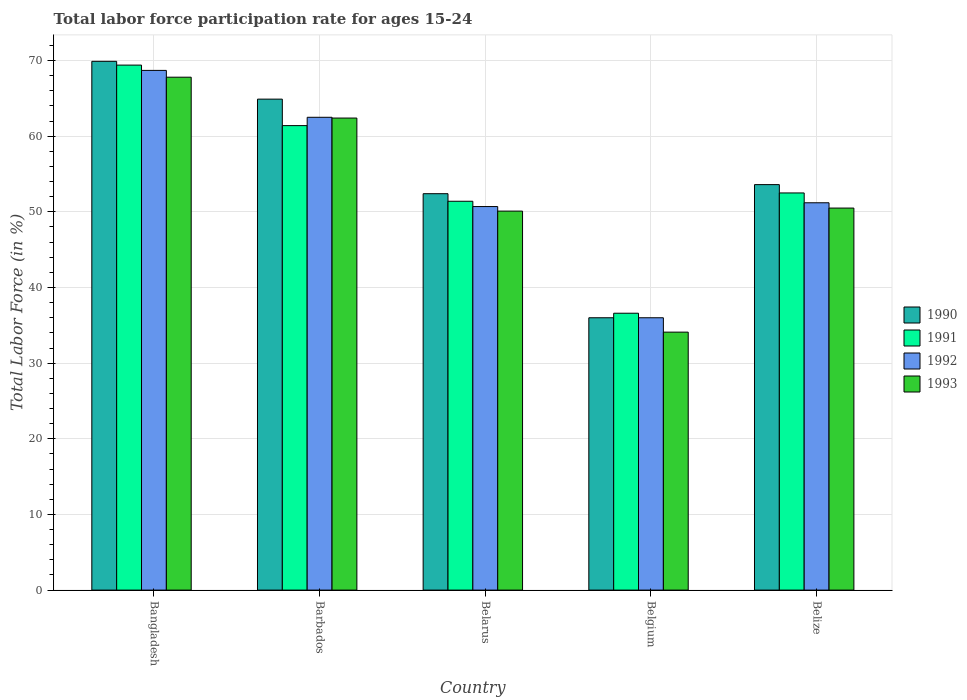Are the number of bars per tick equal to the number of legend labels?
Give a very brief answer. Yes. Are the number of bars on each tick of the X-axis equal?
Make the answer very short. Yes. How many bars are there on the 2nd tick from the left?
Offer a terse response. 4. How many bars are there on the 5th tick from the right?
Provide a succinct answer. 4. What is the label of the 3rd group of bars from the left?
Ensure brevity in your answer.  Belarus. What is the labor force participation rate in 1990 in Belize?
Offer a very short reply. 53.6. Across all countries, what is the maximum labor force participation rate in 1992?
Offer a very short reply. 68.7. Across all countries, what is the minimum labor force participation rate in 1993?
Offer a very short reply. 34.1. In which country was the labor force participation rate in 1991 maximum?
Give a very brief answer. Bangladesh. In which country was the labor force participation rate in 1992 minimum?
Ensure brevity in your answer.  Belgium. What is the total labor force participation rate in 1992 in the graph?
Ensure brevity in your answer.  269.1. What is the difference between the labor force participation rate in 1992 in Bangladesh and that in Barbados?
Provide a succinct answer. 6.2. What is the difference between the labor force participation rate in 1991 in Belarus and the labor force participation rate in 1992 in Barbados?
Make the answer very short. -11.1. What is the average labor force participation rate in 1992 per country?
Your response must be concise. 53.82. What is the difference between the labor force participation rate of/in 1990 and labor force participation rate of/in 1992 in Barbados?
Keep it short and to the point. 2.4. In how many countries, is the labor force participation rate in 1990 greater than 56 %?
Make the answer very short. 2. What is the ratio of the labor force participation rate in 1993 in Barbados to that in Belarus?
Provide a succinct answer. 1.25. What is the difference between the highest and the second highest labor force participation rate in 1990?
Your response must be concise. 11.3. What is the difference between the highest and the lowest labor force participation rate in 1993?
Provide a succinct answer. 33.7. In how many countries, is the labor force participation rate in 1993 greater than the average labor force participation rate in 1993 taken over all countries?
Make the answer very short. 2. Is it the case that in every country, the sum of the labor force participation rate in 1991 and labor force participation rate in 1990 is greater than the sum of labor force participation rate in 1993 and labor force participation rate in 1992?
Provide a short and direct response. No. What does the 4th bar from the left in Belarus represents?
Ensure brevity in your answer.  1993. Is it the case that in every country, the sum of the labor force participation rate in 1990 and labor force participation rate in 1992 is greater than the labor force participation rate in 1991?
Provide a short and direct response. Yes. Are the values on the major ticks of Y-axis written in scientific E-notation?
Make the answer very short. No. Does the graph contain any zero values?
Make the answer very short. No. Where does the legend appear in the graph?
Keep it short and to the point. Center right. How are the legend labels stacked?
Your answer should be compact. Vertical. What is the title of the graph?
Give a very brief answer. Total labor force participation rate for ages 15-24. What is the label or title of the X-axis?
Provide a succinct answer. Country. What is the label or title of the Y-axis?
Your answer should be very brief. Total Labor Force (in %). What is the Total Labor Force (in %) in 1990 in Bangladesh?
Keep it short and to the point. 69.9. What is the Total Labor Force (in %) in 1991 in Bangladesh?
Provide a short and direct response. 69.4. What is the Total Labor Force (in %) of 1992 in Bangladesh?
Make the answer very short. 68.7. What is the Total Labor Force (in %) in 1993 in Bangladesh?
Offer a very short reply. 67.8. What is the Total Labor Force (in %) in 1990 in Barbados?
Provide a succinct answer. 64.9. What is the Total Labor Force (in %) in 1991 in Barbados?
Keep it short and to the point. 61.4. What is the Total Labor Force (in %) in 1992 in Barbados?
Offer a very short reply. 62.5. What is the Total Labor Force (in %) of 1993 in Barbados?
Make the answer very short. 62.4. What is the Total Labor Force (in %) of 1990 in Belarus?
Provide a short and direct response. 52.4. What is the Total Labor Force (in %) of 1991 in Belarus?
Provide a short and direct response. 51.4. What is the Total Labor Force (in %) in 1992 in Belarus?
Provide a short and direct response. 50.7. What is the Total Labor Force (in %) of 1993 in Belarus?
Keep it short and to the point. 50.1. What is the Total Labor Force (in %) in 1991 in Belgium?
Your answer should be compact. 36.6. What is the Total Labor Force (in %) in 1992 in Belgium?
Your answer should be compact. 36. What is the Total Labor Force (in %) of 1993 in Belgium?
Make the answer very short. 34.1. What is the Total Labor Force (in %) of 1990 in Belize?
Make the answer very short. 53.6. What is the Total Labor Force (in %) in 1991 in Belize?
Provide a short and direct response. 52.5. What is the Total Labor Force (in %) of 1992 in Belize?
Your response must be concise. 51.2. What is the Total Labor Force (in %) in 1993 in Belize?
Your response must be concise. 50.5. Across all countries, what is the maximum Total Labor Force (in %) in 1990?
Your response must be concise. 69.9. Across all countries, what is the maximum Total Labor Force (in %) of 1991?
Your answer should be compact. 69.4. Across all countries, what is the maximum Total Labor Force (in %) of 1992?
Provide a short and direct response. 68.7. Across all countries, what is the maximum Total Labor Force (in %) of 1993?
Keep it short and to the point. 67.8. Across all countries, what is the minimum Total Labor Force (in %) in 1991?
Provide a succinct answer. 36.6. Across all countries, what is the minimum Total Labor Force (in %) in 1992?
Keep it short and to the point. 36. Across all countries, what is the minimum Total Labor Force (in %) of 1993?
Provide a succinct answer. 34.1. What is the total Total Labor Force (in %) of 1990 in the graph?
Make the answer very short. 276.8. What is the total Total Labor Force (in %) in 1991 in the graph?
Your answer should be compact. 271.3. What is the total Total Labor Force (in %) in 1992 in the graph?
Offer a very short reply. 269.1. What is the total Total Labor Force (in %) of 1993 in the graph?
Make the answer very short. 264.9. What is the difference between the Total Labor Force (in %) in 1991 in Bangladesh and that in Belarus?
Your response must be concise. 18. What is the difference between the Total Labor Force (in %) in 1993 in Bangladesh and that in Belarus?
Offer a terse response. 17.7. What is the difference between the Total Labor Force (in %) of 1990 in Bangladesh and that in Belgium?
Provide a short and direct response. 33.9. What is the difference between the Total Labor Force (in %) in 1991 in Bangladesh and that in Belgium?
Offer a very short reply. 32.8. What is the difference between the Total Labor Force (in %) of 1992 in Bangladesh and that in Belgium?
Your response must be concise. 32.7. What is the difference between the Total Labor Force (in %) in 1993 in Bangladesh and that in Belgium?
Your response must be concise. 33.7. What is the difference between the Total Labor Force (in %) in 1991 in Bangladesh and that in Belize?
Give a very brief answer. 16.9. What is the difference between the Total Labor Force (in %) of 1990 in Barbados and that in Belarus?
Provide a short and direct response. 12.5. What is the difference between the Total Labor Force (in %) in 1990 in Barbados and that in Belgium?
Offer a terse response. 28.9. What is the difference between the Total Labor Force (in %) in 1991 in Barbados and that in Belgium?
Keep it short and to the point. 24.8. What is the difference between the Total Labor Force (in %) of 1993 in Barbados and that in Belgium?
Provide a succinct answer. 28.3. What is the difference between the Total Labor Force (in %) in 1990 in Barbados and that in Belize?
Your answer should be compact. 11.3. What is the difference between the Total Labor Force (in %) of 1991 in Barbados and that in Belize?
Provide a short and direct response. 8.9. What is the difference between the Total Labor Force (in %) of 1991 in Belarus and that in Belgium?
Provide a succinct answer. 14.8. What is the difference between the Total Labor Force (in %) in 1992 in Belarus and that in Belgium?
Offer a terse response. 14.7. What is the difference between the Total Labor Force (in %) of 1991 in Belarus and that in Belize?
Provide a short and direct response. -1.1. What is the difference between the Total Labor Force (in %) in 1992 in Belarus and that in Belize?
Your answer should be very brief. -0.5. What is the difference between the Total Labor Force (in %) of 1990 in Belgium and that in Belize?
Your answer should be very brief. -17.6. What is the difference between the Total Labor Force (in %) in 1991 in Belgium and that in Belize?
Offer a very short reply. -15.9. What is the difference between the Total Labor Force (in %) in 1992 in Belgium and that in Belize?
Make the answer very short. -15.2. What is the difference between the Total Labor Force (in %) of 1993 in Belgium and that in Belize?
Ensure brevity in your answer.  -16.4. What is the difference between the Total Labor Force (in %) of 1990 in Bangladesh and the Total Labor Force (in %) of 1992 in Barbados?
Provide a short and direct response. 7.4. What is the difference between the Total Labor Force (in %) in 1991 in Bangladesh and the Total Labor Force (in %) in 1993 in Barbados?
Keep it short and to the point. 7. What is the difference between the Total Labor Force (in %) of 1992 in Bangladesh and the Total Labor Force (in %) of 1993 in Barbados?
Offer a terse response. 6.3. What is the difference between the Total Labor Force (in %) in 1990 in Bangladesh and the Total Labor Force (in %) in 1991 in Belarus?
Offer a terse response. 18.5. What is the difference between the Total Labor Force (in %) in 1990 in Bangladesh and the Total Labor Force (in %) in 1993 in Belarus?
Offer a terse response. 19.8. What is the difference between the Total Labor Force (in %) of 1991 in Bangladesh and the Total Labor Force (in %) of 1993 in Belarus?
Your response must be concise. 19.3. What is the difference between the Total Labor Force (in %) in 1992 in Bangladesh and the Total Labor Force (in %) in 1993 in Belarus?
Offer a terse response. 18.6. What is the difference between the Total Labor Force (in %) of 1990 in Bangladesh and the Total Labor Force (in %) of 1991 in Belgium?
Your response must be concise. 33.3. What is the difference between the Total Labor Force (in %) of 1990 in Bangladesh and the Total Labor Force (in %) of 1992 in Belgium?
Your response must be concise. 33.9. What is the difference between the Total Labor Force (in %) of 1990 in Bangladesh and the Total Labor Force (in %) of 1993 in Belgium?
Make the answer very short. 35.8. What is the difference between the Total Labor Force (in %) in 1991 in Bangladesh and the Total Labor Force (in %) in 1992 in Belgium?
Your answer should be compact. 33.4. What is the difference between the Total Labor Force (in %) of 1991 in Bangladesh and the Total Labor Force (in %) of 1993 in Belgium?
Your answer should be compact. 35.3. What is the difference between the Total Labor Force (in %) of 1992 in Bangladesh and the Total Labor Force (in %) of 1993 in Belgium?
Give a very brief answer. 34.6. What is the difference between the Total Labor Force (in %) of 1990 in Bangladesh and the Total Labor Force (in %) of 1991 in Belize?
Your response must be concise. 17.4. What is the difference between the Total Labor Force (in %) of 1990 in Bangladesh and the Total Labor Force (in %) of 1992 in Belize?
Your answer should be very brief. 18.7. What is the difference between the Total Labor Force (in %) of 1990 in Bangladesh and the Total Labor Force (in %) of 1993 in Belize?
Ensure brevity in your answer.  19.4. What is the difference between the Total Labor Force (in %) in 1991 in Bangladesh and the Total Labor Force (in %) in 1993 in Belize?
Ensure brevity in your answer.  18.9. What is the difference between the Total Labor Force (in %) in 1992 in Bangladesh and the Total Labor Force (in %) in 1993 in Belize?
Keep it short and to the point. 18.2. What is the difference between the Total Labor Force (in %) of 1990 in Barbados and the Total Labor Force (in %) of 1992 in Belarus?
Provide a succinct answer. 14.2. What is the difference between the Total Labor Force (in %) in 1990 in Barbados and the Total Labor Force (in %) in 1993 in Belarus?
Your response must be concise. 14.8. What is the difference between the Total Labor Force (in %) in 1991 in Barbados and the Total Labor Force (in %) in 1992 in Belarus?
Make the answer very short. 10.7. What is the difference between the Total Labor Force (in %) of 1992 in Barbados and the Total Labor Force (in %) of 1993 in Belarus?
Your answer should be compact. 12.4. What is the difference between the Total Labor Force (in %) of 1990 in Barbados and the Total Labor Force (in %) of 1991 in Belgium?
Your response must be concise. 28.3. What is the difference between the Total Labor Force (in %) in 1990 in Barbados and the Total Labor Force (in %) in 1992 in Belgium?
Your answer should be very brief. 28.9. What is the difference between the Total Labor Force (in %) of 1990 in Barbados and the Total Labor Force (in %) of 1993 in Belgium?
Your answer should be very brief. 30.8. What is the difference between the Total Labor Force (in %) of 1991 in Barbados and the Total Labor Force (in %) of 1992 in Belgium?
Provide a short and direct response. 25.4. What is the difference between the Total Labor Force (in %) of 1991 in Barbados and the Total Labor Force (in %) of 1993 in Belgium?
Your answer should be compact. 27.3. What is the difference between the Total Labor Force (in %) of 1992 in Barbados and the Total Labor Force (in %) of 1993 in Belgium?
Your response must be concise. 28.4. What is the difference between the Total Labor Force (in %) of 1990 in Barbados and the Total Labor Force (in %) of 1992 in Belize?
Offer a very short reply. 13.7. What is the difference between the Total Labor Force (in %) of 1991 in Barbados and the Total Labor Force (in %) of 1992 in Belize?
Offer a very short reply. 10.2. What is the difference between the Total Labor Force (in %) in 1990 in Belarus and the Total Labor Force (in %) in 1991 in Belgium?
Provide a succinct answer. 15.8. What is the difference between the Total Labor Force (in %) of 1990 in Belarus and the Total Labor Force (in %) of 1993 in Belgium?
Give a very brief answer. 18.3. What is the difference between the Total Labor Force (in %) in 1990 in Belarus and the Total Labor Force (in %) in 1992 in Belize?
Offer a terse response. 1.2. What is the difference between the Total Labor Force (in %) of 1991 in Belarus and the Total Labor Force (in %) of 1993 in Belize?
Keep it short and to the point. 0.9. What is the difference between the Total Labor Force (in %) of 1990 in Belgium and the Total Labor Force (in %) of 1991 in Belize?
Provide a succinct answer. -16.5. What is the difference between the Total Labor Force (in %) of 1990 in Belgium and the Total Labor Force (in %) of 1992 in Belize?
Offer a terse response. -15.2. What is the difference between the Total Labor Force (in %) in 1991 in Belgium and the Total Labor Force (in %) in 1992 in Belize?
Keep it short and to the point. -14.6. What is the difference between the Total Labor Force (in %) in 1991 in Belgium and the Total Labor Force (in %) in 1993 in Belize?
Provide a succinct answer. -13.9. What is the average Total Labor Force (in %) of 1990 per country?
Provide a short and direct response. 55.36. What is the average Total Labor Force (in %) in 1991 per country?
Ensure brevity in your answer.  54.26. What is the average Total Labor Force (in %) of 1992 per country?
Provide a short and direct response. 53.82. What is the average Total Labor Force (in %) of 1993 per country?
Make the answer very short. 52.98. What is the difference between the Total Labor Force (in %) of 1990 and Total Labor Force (in %) of 1992 in Bangladesh?
Keep it short and to the point. 1.2. What is the difference between the Total Labor Force (in %) of 1992 and Total Labor Force (in %) of 1993 in Bangladesh?
Make the answer very short. 0.9. What is the difference between the Total Labor Force (in %) in 1990 and Total Labor Force (in %) in 1992 in Barbados?
Give a very brief answer. 2.4. What is the difference between the Total Labor Force (in %) in 1990 and Total Labor Force (in %) in 1993 in Barbados?
Provide a short and direct response. 2.5. What is the difference between the Total Labor Force (in %) of 1991 and Total Labor Force (in %) of 1992 in Barbados?
Provide a short and direct response. -1.1. What is the difference between the Total Labor Force (in %) of 1991 and Total Labor Force (in %) of 1993 in Barbados?
Give a very brief answer. -1. What is the difference between the Total Labor Force (in %) of 1990 and Total Labor Force (in %) of 1991 in Belarus?
Keep it short and to the point. 1. What is the difference between the Total Labor Force (in %) in 1990 and Total Labor Force (in %) in 1992 in Belarus?
Provide a short and direct response. 1.7. What is the difference between the Total Labor Force (in %) of 1990 and Total Labor Force (in %) of 1993 in Belarus?
Provide a short and direct response. 2.3. What is the difference between the Total Labor Force (in %) in 1991 and Total Labor Force (in %) in 1993 in Belgium?
Keep it short and to the point. 2.5. What is the difference between the Total Labor Force (in %) in 1992 and Total Labor Force (in %) in 1993 in Belgium?
Your response must be concise. 1.9. What is the difference between the Total Labor Force (in %) in 1990 and Total Labor Force (in %) in 1991 in Belize?
Your answer should be very brief. 1.1. What is the difference between the Total Labor Force (in %) of 1990 and Total Labor Force (in %) of 1992 in Belize?
Keep it short and to the point. 2.4. What is the difference between the Total Labor Force (in %) of 1990 and Total Labor Force (in %) of 1993 in Belize?
Offer a terse response. 3.1. What is the difference between the Total Labor Force (in %) of 1991 and Total Labor Force (in %) of 1992 in Belize?
Offer a very short reply. 1.3. What is the difference between the Total Labor Force (in %) of 1992 and Total Labor Force (in %) of 1993 in Belize?
Provide a short and direct response. 0.7. What is the ratio of the Total Labor Force (in %) in 1990 in Bangladesh to that in Barbados?
Keep it short and to the point. 1.08. What is the ratio of the Total Labor Force (in %) of 1991 in Bangladesh to that in Barbados?
Make the answer very short. 1.13. What is the ratio of the Total Labor Force (in %) in 1992 in Bangladesh to that in Barbados?
Your response must be concise. 1.1. What is the ratio of the Total Labor Force (in %) of 1993 in Bangladesh to that in Barbados?
Provide a succinct answer. 1.09. What is the ratio of the Total Labor Force (in %) of 1990 in Bangladesh to that in Belarus?
Offer a terse response. 1.33. What is the ratio of the Total Labor Force (in %) in 1991 in Bangladesh to that in Belarus?
Give a very brief answer. 1.35. What is the ratio of the Total Labor Force (in %) in 1992 in Bangladesh to that in Belarus?
Make the answer very short. 1.35. What is the ratio of the Total Labor Force (in %) in 1993 in Bangladesh to that in Belarus?
Provide a short and direct response. 1.35. What is the ratio of the Total Labor Force (in %) in 1990 in Bangladesh to that in Belgium?
Your answer should be very brief. 1.94. What is the ratio of the Total Labor Force (in %) in 1991 in Bangladesh to that in Belgium?
Make the answer very short. 1.9. What is the ratio of the Total Labor Force (in %) in 1992 in Bangladesh to that in Belgium?
Offer a very short reply. 1.91. What is the ratio of the Total Labor Force (in %) in 1993 in Bangladesh to that in Belgium?
Ensure brevity in your answer.  1.99. What is the ratio of the Total Labor Force (in %) of 1990 in Bangladesh to that in Belize?
Keep it short and to the point. 1.3. What is the ratio of the Total Labor Force (in %) of 1991 in Bangladesh to that in Belize?
Your response must be concise. 1.32. What is the ratio of the Total Labor Force (in %) in 1992 in Bangladesh to that in Belize?
Make the answer very short. 1.34. What is the ratio of the Total Labor Force (in %) in 1993 in Bangladesh to that in Belize?
Provide a short and direct response. 1.34. What is the ratio of the Total Labor Force (in %) in 1990 in Barbados to that in Belarus?
Offer a very short reply. 1.24. What is the ratio of the Total Labor Force (in %) of 1991 in Barbados to that in Belarus?
Your answer should be compact. 1.19. What is the ratio of the Total Labor Force (in %) of 1992 in Barbados to that in Belarus?
Offer a terse response. 1.23. What is the ratio of the Total Labor Force (in %) of 1993 in Barbados to that in Belarus?
Provide a succinct answer. 1.25. What is the ratio of the Total Labor Force (in %) of 1990 in Barbados to that in Belgium?
Provide a short and direct response. 1.8. What is the ratio of the Total Labor Force (in %) of 1991 in Barbados to that in Belgium?
Your answer should be very brief. 1.68. What is the ratio of the Total Labor Force (in %) in 1992 in Barbados to that in Belgium?
Keep it short and to the point. 1.74. What is the ratio of the Total Labor Force (in %) in 1993 in Barbados to that in Belgium?
Your response must be concise. 1.83. What is the ratio of the Total Labor Force (in %) of 1990 in Barbados to that in Belize?
Give a very brief answer. 1.21. What is the ratio of the Total Labor Force (in %) in 1991 in Barbados to that in Belize?
Offer a terse response. 1.17. What is the ratio of the Total Labor Force (in %) of 1992 in Barbados to that in Belize?
Offer a terse response. 1.22. What is the ratio of the Total Labor Force (in %) of 1993 in Barbados to that in Belize?
Provide a short and direct response. 1.24. What is the ratio of the Total Labor Force (in %) in 1990 in Belarus to that in Belgium?
Your answer should be compact. 1.46. What is the ratio of the Total Labor Force (in %) in 1991 in Belarus to that in Belgium?
Your answer should be compact. 1.4. What is the ratio of the Total Labor Force (in %) of 1992 in Belarus to that in Belgium?
Your answer should be compact. 1.41. What is the ratio of the Total Labor Force (in %) of 1993 in Belarus to that in Belgium?
Keep it short and to the point. 1.47. What is the ratio of the Total Labor Force (in %) in 1990 in Belarus to that in Belize?
Offer a very short reply. 0.98. What is the ratio of the Total Labor Force (in %) of 1992 in Belarus to that in Belize?
Keep it short and to the point. 0.99. What is the ratio of the Total Labor Force (in %) of 1990 in Belgium to that in Belize?
Keep it short and to the point. 0.67. What is the ratio of the Total Labor Force (in %) of 1991 in Belgium to that in Belize?
Provide a succinct answer. 0.7. What is the ratio of the Total Labor Force (in %) of 1992 in Belgium to that in Belize?
Your answer should be very brief. 0.7. What is the ratio of the Total Labor Force (in %) of 1993 in Belgium to that in Belize?
Your answer should be compact. 0.68. What is the difference between the highest and the second highest Total Labor Force (in %) of 1992?
Make the answer very short. 6.2. What is the difference between the highest and the lowest Total Labor Force (in %) in 1990?
Offer a very short reply. 33.9. What is the difference between the highest and the lowest Total Labor Force (in %) of 1991?
Provide a succinct answer. 32.8. What is the difference between the highest and the lowest Total Labor Force (in %) in 1992?
Offer a terse response. 32.7. What is the difference between the highest and the lowest Total Labor Force (in %) of 1993?
Offer a very short reply. 33.7. 